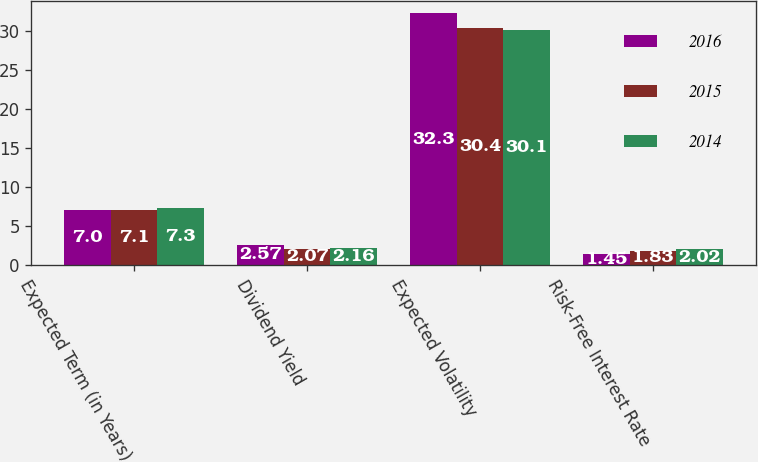Convert chart. <chart><loc_0><loc_0><loc_500><loc_500><stacked_bar_chart><ecel><fcel>Expected Term (in Years)<fcel>Dividend Yield<fcel>Expected Volatility<fcel>Risk-Free Interest Rate<nl><fcel>2016<fcel>7<fcel>2.57<fcel>32.3<fcel>1.45<nl><fcel>2015<fcel>7.1<fcel>2.07<fcel>30.4<fcel>1.83<nl><fcel>2014<fcel>7.3<fcel>2.16<fcel>30.1<fcel>2.02<nl></chart> 